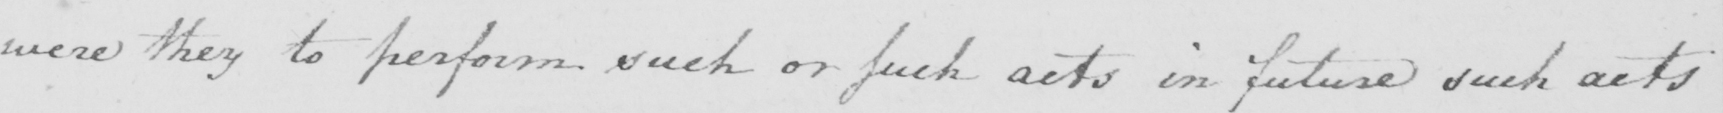Transcribe the text shown in this historical manuscript line. were they to perform such or such acts in future such acts 